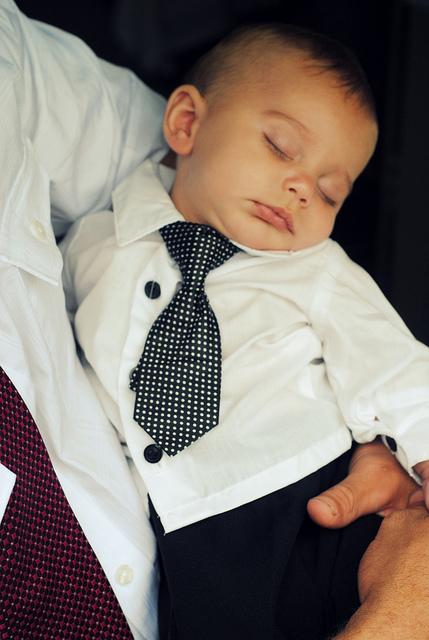Is the boy smiling?
Give a very brief answer. No. How is the baby laying on, a male or a female?
Keep it brief. Male. Is the baby wearing a bib?
Quick response, please. No. Does the baby look peaceful?
Short answer required. Yes. Is this baby awake?
Keep it brief. No. 